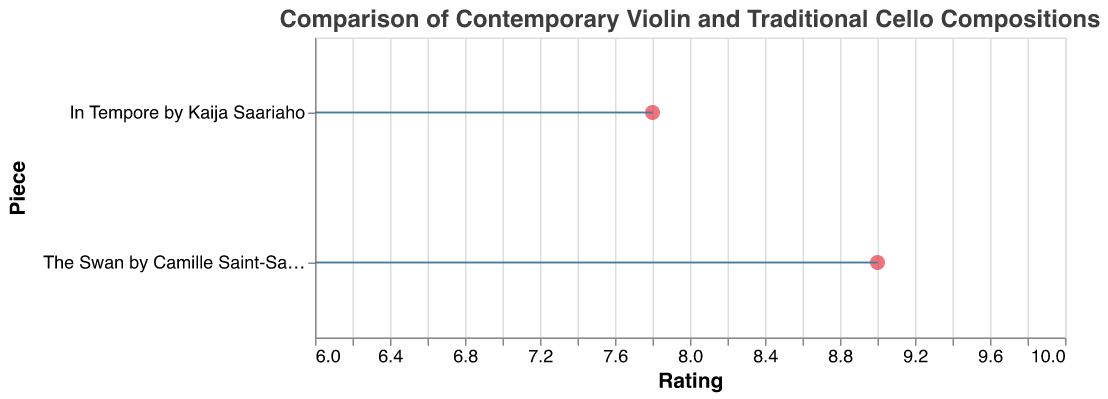What is the title of the plot? The title is displayed at the top of the plot. It reads "Comparison of Contemporary Violin and Traditional Cello Compositions".
Answer: Comparison of Contemporary Violin and Traditional Cello Compositions How many compositions are compared in the plot? The plot displays two points, each representing one composition.
Answer: Two What is the average rating of "In Tempore" by Kaija Saariaho? The point corresponding to "In Tempore" by Kaija Saariaho is at an x-value of 7.8, indicating its average rating.
Answer: 7.8 Which composition has the higher average rating? Comparing the x-values of the two points, "The Swan" by Camille Saint-Saëns has a higher average rating of 9.0, while "In Tempore" by Kaija Saariaho has an average rating of 7.8.
Answer: The Swan by Camille Saint-Saëns What does the length of the horizontal line extending from each point represent? The horizontal lines extending from each point represent one standard deviation above and below the average rating for each composition.
Answer: One standard deviation How does the standard deviation of "In Tempore" compare to the standard deviation of "The Swan"? The length of the horizontal line (standard deviation) for "In Tempore" (0.8) is longer than that for "The Swan" (0.3), suggesting more variability in the ratings of "In Tempore".
Answer: Greater for "In Tempore" What's the range of ratings covered by "The Swan" by Camille Saint-Saëns based on its average rating and standard deviation? Adding and subtracting the standard deviation (0.3) from the average rating (9.0) gives the range: 8.7 to 9.3.
Answer: 8.7 to 9.3 Which composition shows more consistency in its reviews? "The Swan" by Camille Saint-Saëns shows more consistency, as indicated by its shorter horizontal line (standard deviation of 0.3) compared to "In Tempore" by Kaija Saariaho (standard deviation of 0.8).
Answer: The Swan by Camille Saint-Saëns Which piece has a larger variation in ratings based on the standard deviation? "In Tempore" by Kaija Saariaho has a larger variation in ratings indicated by a longer standard deviation line (0.8) compared to "The Swan" by Camille Saint-Saëns (0.3).
Answer: In Tempore by Kaija Saariaho 